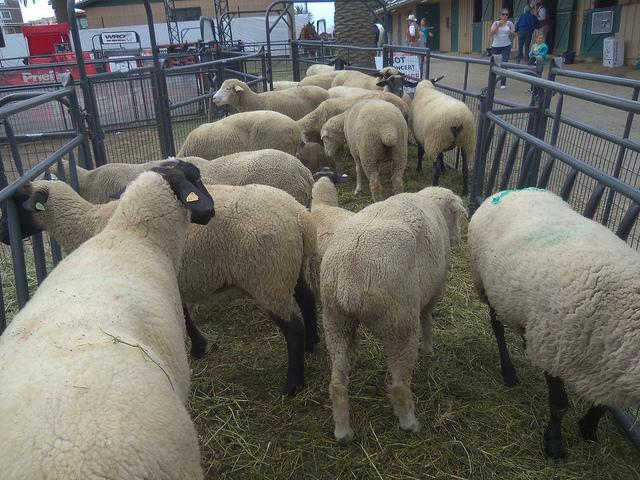What feature do these animals have? Please explain your reasoning. wool. The sheep have wool. 